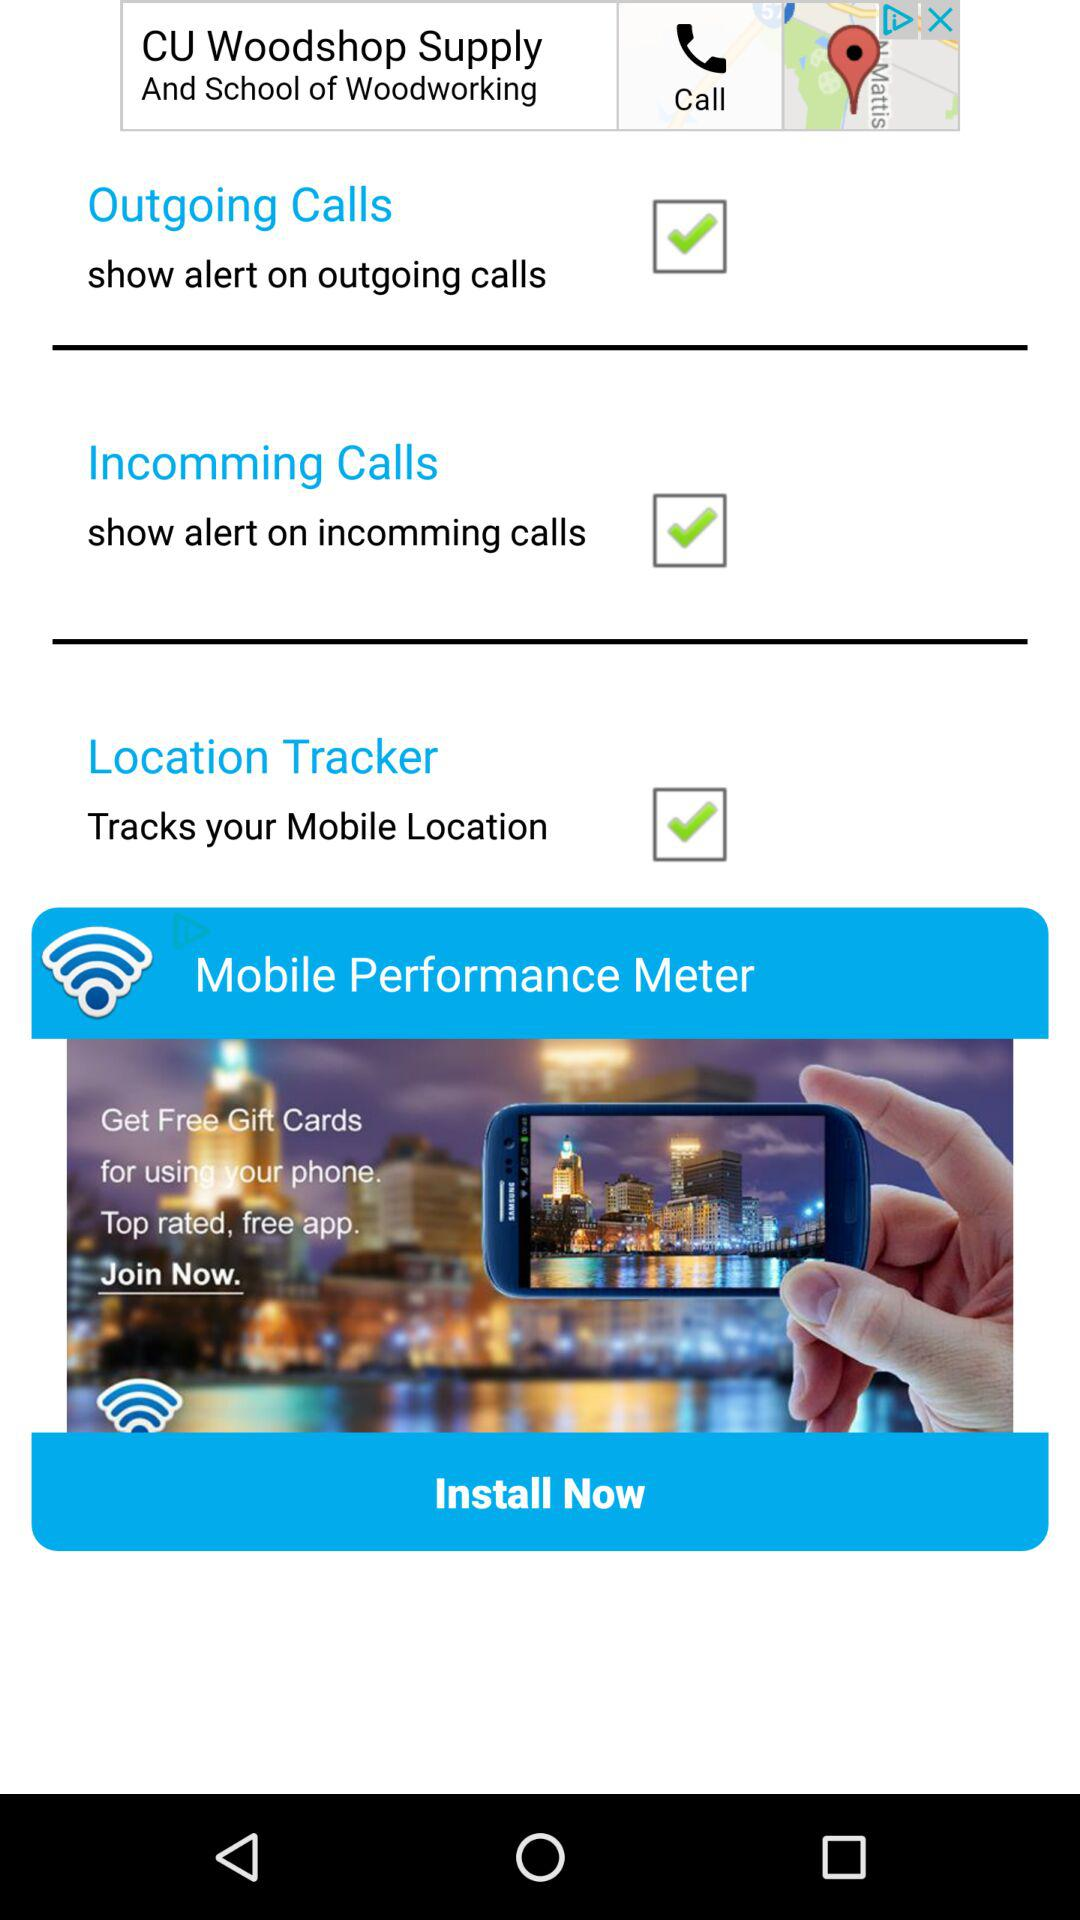What is the status of "Outgoing Calls"? The status is "on". 